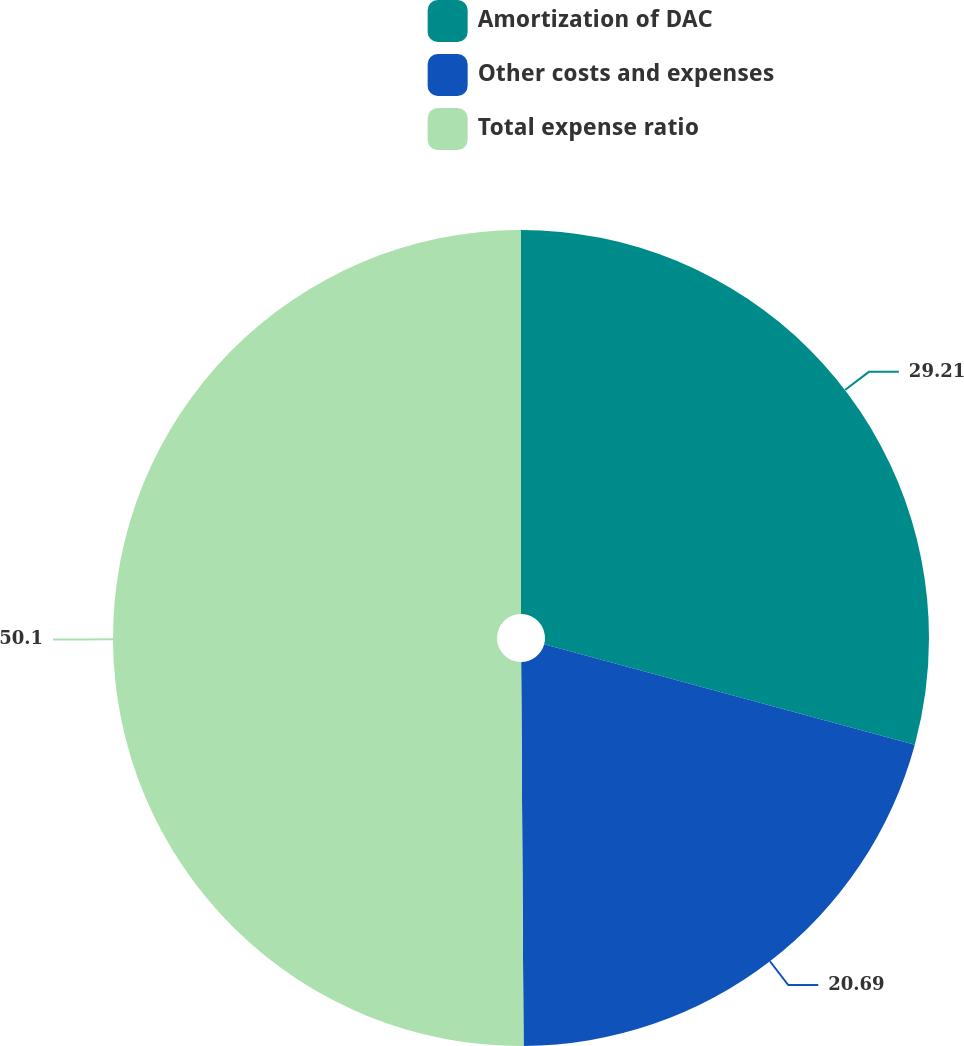<chart> <loc_0><loc_0><loc_500><loc_500><pie_chart><fcel>Amortization of DAC<fcel>Other costs and expenses<fcel>Total expense ratio<nl><fcel>29.21%<fcel>20.69%<fcel>50.1%<nl></chart> 